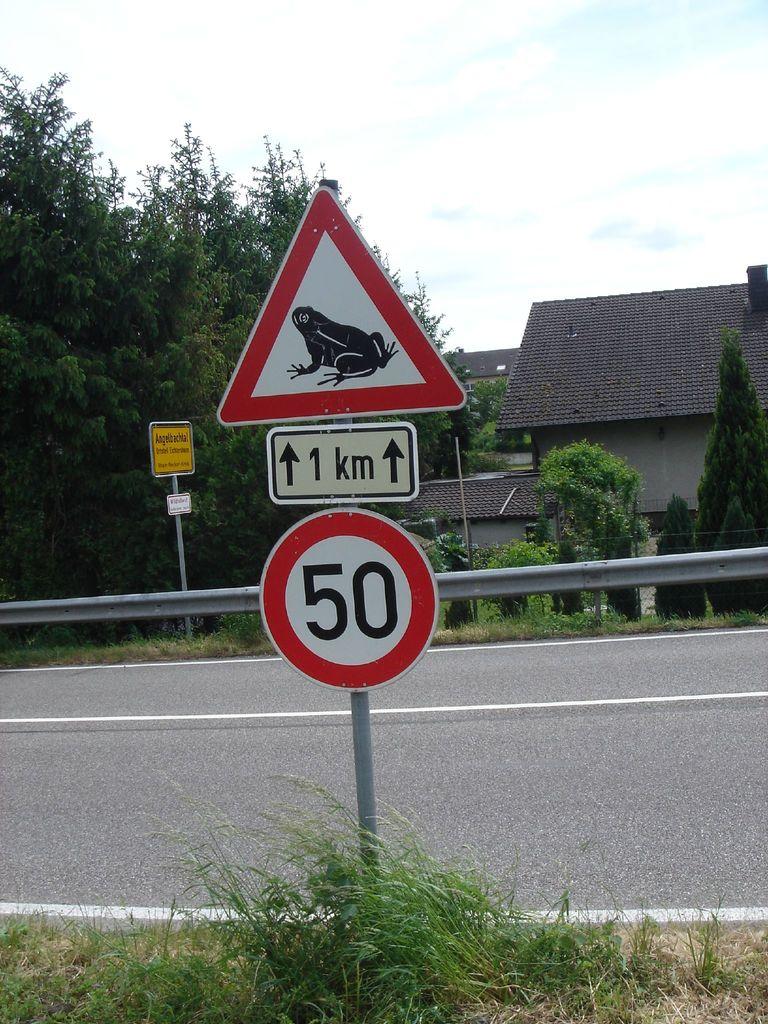What is the sign warning about?
Make the answer very short. Answering does not require reading text in the image. 